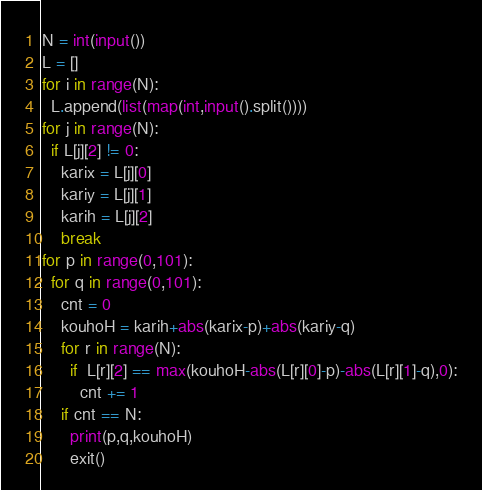<code> <loc_0><loc_0><loc_500><loc_500><_Python_>N = int(input())
L = []
for i in range(N):
  L.append(list(map(int,input().split())))
for j in range(N):
  if L[j][2] != 0:
    karix = L[j][0]
    kariy = L[j][1]
    karih = L[j][2]
    break
for p in range(0,101):
  for q in range(0,101):
    cnt = 0
    kouhoH = karih+abs(karix-p)+abs(kariy-q)
    for r in range(N):
      if  L[r][2] == max(kouhoH-abs(L[r][0]-p)-abs(L[r][1]-q),0):
        cnt += 1
    if cnt == N:
      print(p,q,kouhoH)
      exit()</code> 